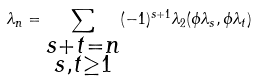Convert formula to latex. <formula><loc_0><loc_0><loc_500><loc_500>\lambda _ { n } = \sum _ { \substack { s + t = n \\ s , t \geq 1 } } ( - 1 ) ^ { s + 1 } \lambda _ { 2 } ( \phi \lambda _ { s } , \phi \lambda _ { t } )</formula> 